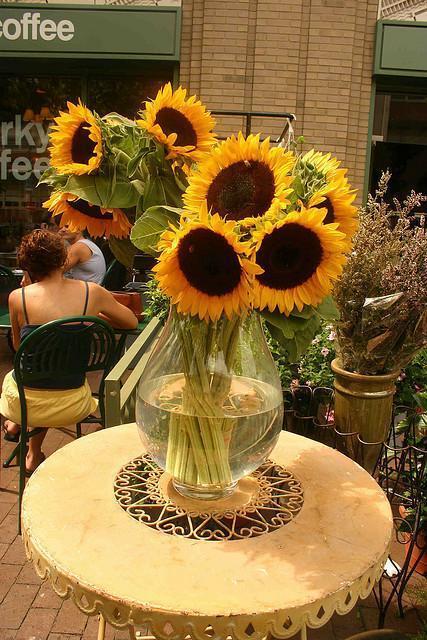How many vases are there?
Give a very brief answer. 2. How many of the dogs playing are brown?
Give a very brief answer. 0. 